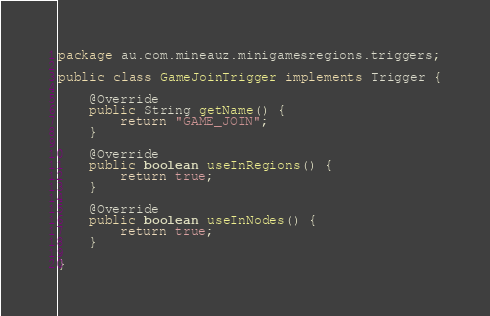Convert code to text. <code><loc_0><loc_0><loc_500><loc_500><_Java_>package au.com.mineauz.minigamesregions.triggers;

public class GameJoinTrigger implements Trigger {

	@Override
	public String getName() {
		return "GAME_JOIN";
	}

	@Override
	public boolean useInRegions() {
		return true;
	}

	@Override
	public boolean useInNodes() {
		return true;
	}

}
</code> 